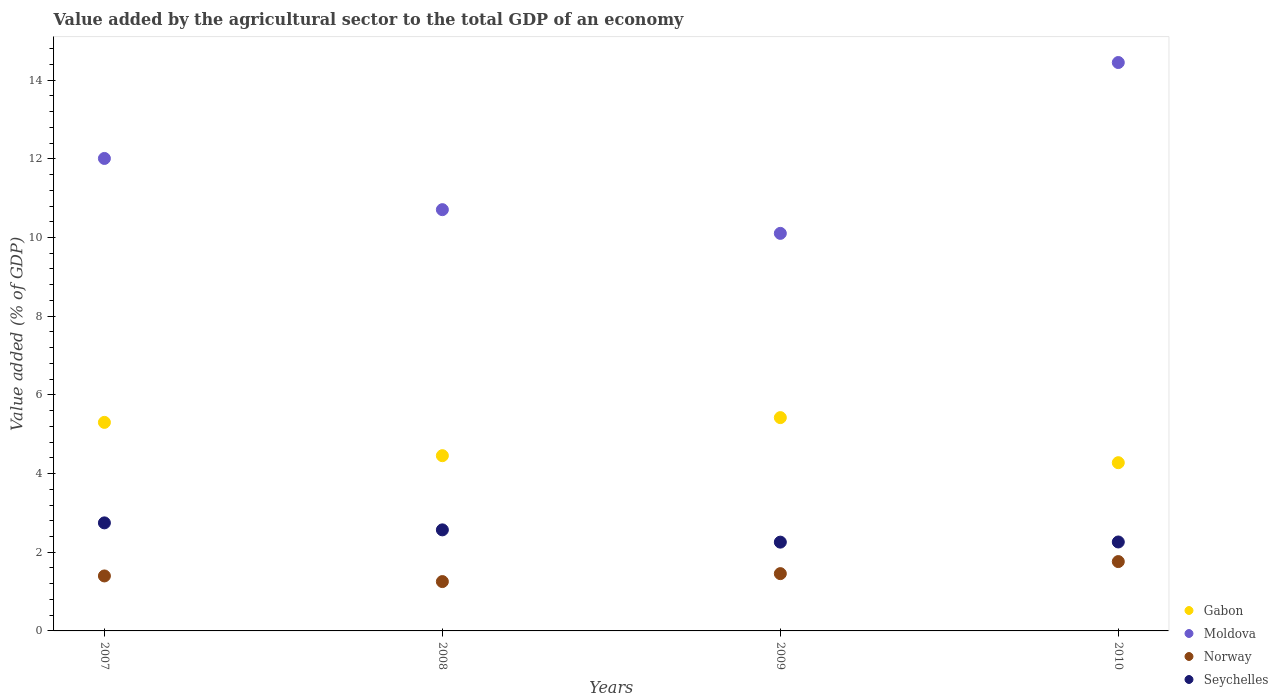What is the value added by the agricultural sector to the total GDP in Norway in 2009?
Keep it short and to the point. 1.46. Across all years, what is the maximum value added by the agricultural sector to the total GDP in Norway?
Keep it short and to the point. 1.76. Across all years, what is the minimum value added by the agricultural sector to the total GDP in Moldova?
Keep it short and to the point. 10.11. In which year was the value added by the agricultural sector to the total GDP in Seychelles maximum?
Your answer should be very brief. 2007. In which year was the value added by the agricultural sector to the total GDP in Seychelles minimum?
Keep it short and to the point. 2009. What is the total value added by the agricultural sector to the total GDP in Moldova in the graph?
Offer a terse response. 47.27. What is the difference between the value added by the agricultural sector to the total GDP in Seychelles in 2007 and that in 2010?
Your answer should be very brief. 0.49. What is the difference between the value added by the agricultural sector to the total GDP in Seychelles in 2009 and the value added by the agricultural sector to the total GDP in Moldova in 2008?
Provide a succinct answer. -8.45. What is the average value added by the agricultural sector to the total GDP in Moldova per year?
Offer a very short reply. 11.82. In the year 2008, what is the difference between the value added by the agricultural sector to the total GDP in Moldova and value added by the agricultural sector to the total GDP in Gabon?
Keep it short and to the point. 6.25. In how many years, is the value added by the agricultural sector to the total GDP in Seychelles greater than 5.6 %?
Offer a terse response. 0. What is the ratio of the value added by the agricultural sector to the total GDP in Seychelles in 2007 to that in 2009?
Ensure brevity in your answer.  1.22. Is the difference between the value added by the agricultural sector to the total GDP in Moldova in 2008 and 2009 greater than the difference between the value added by the agricultural sector to the total GDP in Gabon in 2008 and 2009?
Your response must be concise. Yes. What is the difference between the highest and the second highest value added by the agricultural sector to the total GDP in Norway?
Your response must be concise. 0.31. What is the difference between the highest and the lowest value added by the agricultural sector to the total GDP in Gabon?
Your answer should be very brief. 1.15. In how many years, is the value added by the agricultural sector to the total GDP in Norway greater than the average value added by the agricultural sector to the total GDP in Norway taken over all years?
Your response must be concise. 1. Is it the case that in every year, the sum of the value added by the agricultural sector to the total GDP in Seychelles and value added by the agricultural sector to the total GDP in Gabon  is greater than the sum of value added by the agricultural sector to the total GDP in Moldova and value added by the agricultural sector to the total GDP in Norway?
Give a very brief answer. No. Is the value added by the agricultural sector to the total GDP in Moldova strictly less than the value added by the agricultural sector to the total GDP in Gabon over the years?
Offer a very short reply. No. Are the values on the major ticks of Y-axis written in scientific E-notation?
Offer a terse response. No. How are the legend labels stacked?
Give a very brief answer. Vertical. What is the title of the graph?
Keep it short and to the point. Value added by the agricultural sector to the total GDP of an economy. What is the label or title of the X-axis?
Offer a very short reply. Years. What is the label or title of the Y-axis?
Make the answer very short. Value added (% of GDP). What is the Value added (% of GDP) of Gabon in 2007?
Offer a very short reply. 5.3. What is the Value added (% of GDP) of Moldova in 2007?
Ensure brevity in your answer.  12.01. What is the Value added (% of GDP) of Norway in 2007?
Ensure brevity in your answer.  1.4. What is the Value added (% of GDP) in Seychelles in 2007?
Your answer should be very brief. 2.75. What is the Value added (% of GDP) in Gabon in 2008?
Keep it short and to the point. 4.45. What is the Value added (% of GDP) of Moldova in 2008?
Ensure brevity in your answer.  10.71. What is the Value added (% of GDP) of Norway in 2008?
Offer a terse response. 1.25. What is the Value added (% of GDP) in Seychelles in 2008?
Your answer should be compact. 2.57. What is the Value added (% of GDP) in Gabon in 2009?
Your answer should be compact. 5.42. What is the Value added (% of GDP) of Moldova in 2009?
Offer a terse response. 10.11. What is the Value added (% of GDP) of Norway in 2009?
Provide a succinct answer. 1.46. What is the Value added (% of GDP) of Seychelles in 2009?
Provide a succinct answer. 2.26. What is the Value added (% of GDP) in Gabon in 2010?
Your answer should be very brief. 4.28. What is the Value added (% of GDP) in Moldova in 2010?
Give a very brief answer. 14.45. What is the Value added (% of GDP) in Norway in 2010?
Give a very brief answer. 1.76. What is the Value added (% of GDP) of Seychelles in 2010?
Provide a succinct answer. 2.26. Across all years, what is the maximum Value added (% of GDP) of Gabon?
Your response must be concise. 5.42. Across all years, what is the maximum Value added (% of GDP) of Moldova?
Offer a very short reply. 14.45. Across all years, what is the maximum Value added (% of GDP) of Norway?
Your response must be concise. 1.76. Across all years, what is the maximum Value added (% of GDP) of Seychelles?
Keep it short and to the point. 2.75. Across all years, what is the minimum Value added (% of GDP) of Gabon?
Give a very brief answer. 4.28. Across all years, what is the minimum Value added (% of GDP) in Moldova?
Make the answer very short. 10.11. Across all years, what is the minimum Value added (% of GDP) of Norway?
Give a very brief answer. 1.25. Across all years, what is the minimum Value added (% of GDP) in Seychelles?
Ensure brevity in your answer.  2.26. What is the total Value added (% of GDP) of Gabon in the graph?
Offer a terse response. 19.45. What is the total Value added (% of GDP) in Moldova in the graph?
Give a very brief answer. 47.27. What is the total Value added (% of GDP) of Norway in the graph?
Give a very brief answer. 5.87. What is the total Value added (% of GDP) of Seychelles in the graph?
Provide a short and direct response. 9.83. What is the difference between the Value added (% of GDP) of Gabon in 2007 and that in 2008?
Ensure brevity in your answer.  0.85. What is the difference between the Value added (% of GDP) of Moldova in 2007 and that in 2008?
Your answer should be very brief. 1.3. What is the difference between the Value added (% of GDP) in Norway in 2007 and that in 2008?
Make the answer very short. 0.14. What is the difference between the Value added (% of GDP) of Seychelles in 2007 and that in 2008?
Provide a succinct answer. 0.18. What is the difference between the Value added (% of GDP) of Gabon in 2007 and that in 2009?
Make the answer very short. -0.12. What is the difference between the Value added (% of GDP) of Moldova in 2007 and that in 2009?
Ensure brevity in your answer.  1.9. What is the difference between the Value added (% of GDP) in Norway in 2007 and that in 2009?
Provide a succinct answer. -0.06. What is the difference between the Value added (% of GDP) of Seychelles in 2007 and that in 2009?
Offer a very short reply. 0.49. What is the difference between the Value added (% of GDP) of Gabon in 2007 and that in 2010?
Provide a succinct answer. 1.02. What is the difference between the Value added (% of GDP) of Moldova in 2007 and that in 2010?
Your response must be concise. -2.44. What is the difference between the Value added (% of GDP) of Norway in 2007 and that in 2010?
Give a very brief answer. -0.36. What is the difference between the Value added (% of GDP) of Seychelles in 2007 and that in 2010?
Make the answer very short. 0.49. What is the difference between the Value added (% of GDP) in Gabon in 2008 and that in 2009?
Your answer should be compact. -0.97. What is the difference between the Value added (% of GDP) of Moldova in 2008 and that in 2009?
Give a very brief answer. 0.6. What is the difference between the Value added (% of GDP) in Norway in 2008 and that in 2009?
Offer a very short reply. -0.2. What is the difference between the Value added (% of GDP) of Seychelles in 2008 and that in 2009?
Keep it short and to the point. 0.31. What is the difference between the Value added (% of GDP) in Gabon in 2008 and that in 2010?
Provide a short and direct response. 0.18. What is the difference between the Value added (% of GDP) of Moldova in 2008 and that in 2010?
Give a very brief answer. -3.74. What is the difference between the Value added (% of GDP) in Norway in 2008 and that in 2010?
Ensure brevity in your answer.  -0.51. What is the difference between the Value added (% of GDP) of Seychelles in 2008 and that in 2010?
Ensure brevity in your answer.  0.31. What is the difference between the Value added (% of GDP) of Gabon in 2009 and that in 2010?
Make the answer very short. 1.15. What is the difference between the Value added (% of GDP) in Moldova in 2009 and that in 2010?
Offer a very short reply. -4.34. What is the difference between the Value added (% of GDP) in Norway in 2009 and that in 2010?
Your response must be concise. -0.31. What is the difference between the Value added (% of GDP) of Seychelles in 2009 and that in 2010?
Offer a terse response. -0. What is the difference between the Value added (% of GDP) in Gabon in 2007 and the Value added (% of GDP) in Moldova in 2008?
Your response must be concise. -5.41. What is the difference between the Value added (% of GDP) in Gabon in 2007 and the Value added (% of GDP) in Norway in 2008?
Keep it short and to the point. 4.05. What is the difference between the Value added (% of GDP) of Gabon in 2007 and the Value added (% of GDP) of Seychelles in 2008?
Provide a succinct answer. 2.73. What is the difference between the Value added (% of GDP) in Moldova in 2007 and the Value added (% of GDP) in Norway in 2008?
Give a very brief answer. 10.76. What is the difference between the Value added (% of GDP) in Moldova in 2007 and the Value added (% of GDP) in Seychelles in 2008?
Give a very brief answer. 9.44. What is the difference between the Value added (% of GDP) in Norway in 2007 and the Value added (% of GDP) in Seychelles in 2008?
Your answer should be very brief. -1.17. What is the difference between the Value added (% of GDP) of Gabon in 2007 and the Value added (% of GDP) of Moldova in 2009?
Offer a terse response. -4.8. What is the difference between the Value added (% of GDP) in Gabon in 2007 and the Value added (% of GDP) in Norway in 2009?
Offer a very short reply. 3.84. What is the difference between the Value added (% of GDP) of Gabon in 2007 and the Value added (% of GDP) of Seychelles in 2009?
Your answer should be compact. 3.04. What is the difference between the Value added (% of GDP) of Moldova in 2007 and the Value added (% of GDP) of Norway in 2009?
Make the answer very short. 10.55. What is the difference between the Value added (% of GDP) in Moldova in 2007 and the Value added (% of GDP) in Seychelles in 2009?
Provide a succinct answer. 9.75. What is the difference between the Value added (% of GDP) in Norway in 2007 and the Value added (% of GDP) in Seychelles in 2009?
Offer a terse response. -0.86. What is the difference between the Value added (% of GDP) in Gabon in 2007 and the Value added (% of GDP) in Moldova in 2010?
Your answer should be very brief. -9.15. What is the difference between the Value added (% of GDP) in Gabon in 2007 and the Value added (% of GDP) in Norway in 2010?
Ensure brevity in your answer.  3.54. What is the difference between the Value added (% of GDP) in Gabon in 2007 and the Value added (% of GDP) in Seychelles in 2010?
Your answer should be compact. 3.04. What is the difference between the Value added (% of GDP) of Moldova in 2007 and the Value added (% of GDP) of Norway in 2010?
Provide a short and direct response. 10.25. What is the difference between the Value added (% of GDP) of Moldova in 2007 and the Value added (% of GDP) of Seychelles in 2010?
Keep it short and to the point. 9.75. What is the difference between the Value added (% of GDP) of Norway in 2007 and the Value added (% of GDP) of Seychelles in 2010?
Your answer should be very brief. -0.86. What is the difference between the Value added (% of GDP) in Gabon in 2008 and the Value added (% of GDP) in Moldova in 2009?
Your answer should be compact. -5.65. What is the difference between the Value added (% of GDP) in Gabon in 2008 and the Value added (% of GDP) in Norway in 2009?
Your answer should be very brief. 3. What is the difference between the Value added (% of GDP) in Gabon in 2008 and the Value added (% of GDP) in Seychelles in 2009?
Give a very brief answer. 2.2. What is the difference between the Value added (% of GDP) in Moldova in 2008 and the Value added (% of GDP) in Norway in 2009?
Your answer should be compact. 9.25. What is the difference between the Value added (% of GDP) of Moldova in 2008 and the Value added (% of GDP) of Seychelles in 2009?
Your answer should be compact. 8.45. What is the difference between the Value added (% of GDP) of Norway in 2008 and the Value added (% of GDP) of Seychelles in 2009?
Your answer should be compact. -1. What is the difference between the Value added (% of GDP) of Gabon in 2008 and the Value added (% of GDP) of Moldova in 2010?
Your answer should be compact. -9.99. What is the difference between the Value added (% of GDP) of Gabon in 2008 and the Value added (% of GDP) of Norway in 2010?
Your answer should be compact. 2.69. What is the difference between the Value added (% of GDP) of Gabon in 2008 and the Value added (% of GDP) of Seychelles in 2010?
Ensure brevity in your answer.  2.19. What is the difference between the Value added (% of GDP) of Moldova in 2008 and the Value added (% of GDP) of Norway in 2010?
Offer a terse response. 8.95. What is the difference between the Value added (% of GDP) in Moldova in 2008 and the Value added (% of GDP) in Seychelles in 2010?
Provide a short and direct response. 8.45. What is the difference between the Value added (% of GDP) of Norway in 2008 and the Value added (% of GDP) of Seychelles in 2010?
Provide a succinct answer. -1.01. What is the difference between the Value added (% of GDP) of Gabon in 2009 and the Value added (% of GDP) of Moldova in 2010?
Offer a terse response. -9.03. What is the difference between the Value added (% of GDP) of Gabon in 2009 and the Value added (% of GDP) of Norway in 2010?
Provide a succinct answer. 3.66. What is the difference between the Value added (% of GDP) of Gabon in 2009 and the Value added (% of GDP) of Seychelles in 2010?
Your answer should be compact. 3.16. What is the difference between the Value added (% of GDP) in Moldova in 2009 and the Value added (% of GDP) in Norway in 2010?
Provide a succinct answer. 8.34. What is the difference between the Value added (% of GDP) in Moldova in 2009 and the Value added (% of GDP) in Seychelles in 2010?
Provide a short and direct response. 7.84. What is the difference between the Value added (% of GDP) of Norway in 2009 and the Value added (% of GDP) of Seychelles in 2010?
Ensure brevity in your answer.  -0.8. What is the average Value added (% of GDP) of Gabon per year?
Provide a succinct answer. 4.86. What is the average Value added (% of GDP) in Moldova per year?
Offer a very short reply. 11.82. What is the average Value added (% of GDP) of Norway per year?
Provide a short and direct response. 1.47. What is the average Value added (% of GDP) in Seychelles per year?
Your answer should be very brief. 2.46. In the year 2007, what is the difference between the Value added (% of GDP) in Gabon and Value added (% of GDP) in Moldova?
Your response must be concise. -6.71. In the year 2007, what is the difference between the Value added (% of GDP) in Gabon and Value added (% of GDP) in Norway?
Ensure brevity in your answer.  3.9. In the year 2007, what is the difference between the Value added (% of GDP) in Gabon and Value added (% of GDP) in Seychelles?
Your answer should be compact. 2.55. In the year 2007, what is the difference between the Value added (% of GDP) of Moldova and Value added (% of GDP) of Norway?
Your answer should be very brief. 10.61. In the year 2007, what is the difference between the Value added (% of GDP) in Moldova and Value added (% of GDP) in Seychelles?
Give a very brief answer. 9.26. In the year 2007, what is the difference between the Value added (% of GDP) of Norway and Value added (% of GDP) of Seychelles?
Your response must be concise. -1.35. In the year 2008, what is the difference between the Value added (% of GDP) in Gabon and Value added (% of GDP) in Moldova?
Provide a short and direct response. -6.25. In the year 2008, what is the difference between the Value added (% of GDP) in Gabon and Value added (% of GDP) in Norway?
Your answer should be compact. 3.2. In the year 2008, what is the difference between the Value added (% of GDP) of Gabon and Value added (% of GDP) of Seychelles?
Offer a terse response. 1.89. In the year 2008, what is the difference between the Value added (% of GDP) of Moldova and Value added (% of GDP) of Norway?
Keep it short and to the point. 9.45. In the year 2008, what is the difference between the Value added (% of GDP) of Moldova and Value added (% of GDP) of Seychelles?
Give a very brief answer. 8.14. In the year 2008, what is the difference between the Value added (% of GDP) of Norway and Value added (% of GDP) of Seychelles?
Provide a succinct answer. -1.31. In the year 2009, what is the difference between the Value added (% of GDP) in Gabon and Value added (% of GDP) in Moldova?
Provide a short and direct response. -4.68. In the year 2009, what is the difference between the Value added (% of GDP) of Gabon and Value added (% of GDP) of Norway?
Your answer should be compact. 3.97. In the year 2009, what is the difference between the Value added (% of GDP) of Gabon and Value added (% of GDP) of Seychelles?
Make the answer very short. 3.17. In the year 2009, what is the difference between the Value added (% of GDP) of Moldova and Value added (% of GDP) of Norway?
Keep it short and to the point. 8.65. In the year 2009, what is the difference between the Value added (% of GDP) in Moldova and Value added (% of GDP) in Seychelles?
Your answer should be compact. 7.85. In the year 2009, what is the difference between the Value added (% of GDP) of Norway and Value added (% of GDP) of Seychelles?
Keep it short and to the point. -0.8. In the year 2010, what is the difference between the Value added (% of GDP) in Gabon and Value added (% of GDP) in Moldova?
Offer a very short reply. -10.17. In the year 2010, what is the difference between the Value added (% of GDP) in Gabon and Value added (% of GDP) in Norway?
Give a very brief answer. 2.51. In the year 2010, what is the difference between the Value added (% of GDP) in Gabon and Value added (% of GDP) in Seychelles?
Ensure brevity in your answer.  2.02. In the year 2010, what is the difference between the Value added (% of GDP) of Moldova and Value added (% of GDP) of Norway?
Make the answer very short. 12.69. In the year 2010, what is the difference between the Value added (% of GDP) of Moldova and Value added (% of GDP) of Seychelles?
Provide a succinct answer. 12.19. In the year 2010, what is the difference between the Value added (% of GDP) of Norway and Value added (% of GDP) of Seychelles?
Keep it short and to the point. -0.5. What is the ratio of the Value added (% of GDP) of Gabon in 2007 to that in 2008?
Give a very brief answer. 1.19. What is the ratio of the Value added (% of GDP) in Moldova in 2007 to that in 2008?
Make the answer very short. 1.12. What is the ratio of the Value added (% of GDP) in Norway in 2007 to that in 2008?
Provide a succinct answer. 1.11. What is the ratio of the Value added (% of GDP) of Seychelles in 2007 to that in 2008?
Offer a very short reply. 1.07. What is the ratio of the Value added (% of GDP) of Gabon in 2007 to that in 2009?
Your answer should be compact. 0.98. What is the ratio of the Value added (% of GDP) of Moldova in 2007 to that in 2009?
Offer a terse response. 1.19. What is the ratio of the Value added (% of GDP) of Norway in 2007 to that in 2009?
Your response must be concise. 0.96. What is the ratio of the Value added (% of GDP) in Seychelles in 2007 to that in 2009?
Give a very brief answer. 1.22. What is the ratio of the Value added (% of GDP) in Gabon in 2007 to that in 2010?
Your answer should be very brief. 1.24. What is the ratio of the Value added (% of GDP) of Moldova in 2007 to that in 2010?
Provide a succinct answer. 0.83. What is the ratio of the Value added (% of GDP) in Norway in 2007 to that in 2010?
Make the answer very short. 0.79. What is the ratio of the Value added (% of GDP) of Seychelles in 2007 to that in 2010?
Make the answer very short. 1.21. What is the ratio of the Value added (% of GDP) in Gabon in 2008 to that in 2009?
Offer a very short reply. 0.82. What is the ratio of the Value added (% of GDP) of Moldova in 2008 to that in 2009?
Provide a succinct answer. 1.06. What is the ratio of the Value added (% of GDP) of Norway in 2008 to that in 2009?
Offer a terse response. 0.86. What is the ratio of the Value added (% of GDP) in Seychelles in 2008 to that in 2009?
Keep it short and to the point. 1.14. What is the ratio of the Value added (% of GDP) in Gabon in 2008 to that in 2010?
Offer a terse response. 1.04. What is the ratio of the Value added (% of GDP) of Moldova in 2008 to that in 2010?
Ensure brevity in your answer.  0.74. What is the ratio of the Value added (% of GDP) in Norway in 2008 to that in 2010?
Your answer should be very brief. 0.71. What is the ratio of the Value added (% of GDP) of Seychelles in 2008 to that in 2010?
Ensure brevity in your answer.  1.14. What is the ratio of the Value added (% of GDP) in Gabon in 2009 to that in 2010?
Provide a succinct answer. 1.27. What is the ratio of the Value added (% of GDP) of Moldova in 2009 to that in 2010?
Provide a short and direct response. 0.7. What is the ratio of the Value added (% of GDP) of Norway in 2009 to that in 2010?
Make the answer very short. 0.83. What is the ratio of the Value added (% of GDP) of Seychelles in 2009 to that in 2010?
Provide a short and direct response. 1. What is the difference between the highest and the second highest Value added (% of GDP) of Gabon?
Ensure brevity in your answer.  0.12. What is the difference between the highest and the second highest Value added (% of GDP) in Moldova?
Ensure brevity in your answer.  2.44. What is the difference between the highest and the second highest Value added (% of GDP) in Norway?
Ensure brevity in your answer.  0.31. What is the difference between the highest and the second highest Value added (% of GDP) of Seychelles?
Your answer should be compact. 0.18. What is the difference between the highest and the lowest Value added (% of GDP) in Gabon?
Provide a succinct answer. 1.15. What is the difference between the highest and the lowest Value added (% of GDP) of Moldova?
Offer a terse response. 4.34. What is the difference between the highest and the lowest Value added (% of GDP) in Norway?
Offer a terse response. 0.51. What is the difference between the highest and the lowest Value added (% of GDP) of Seychelles?
Keep it short and to the point. 0.49. 